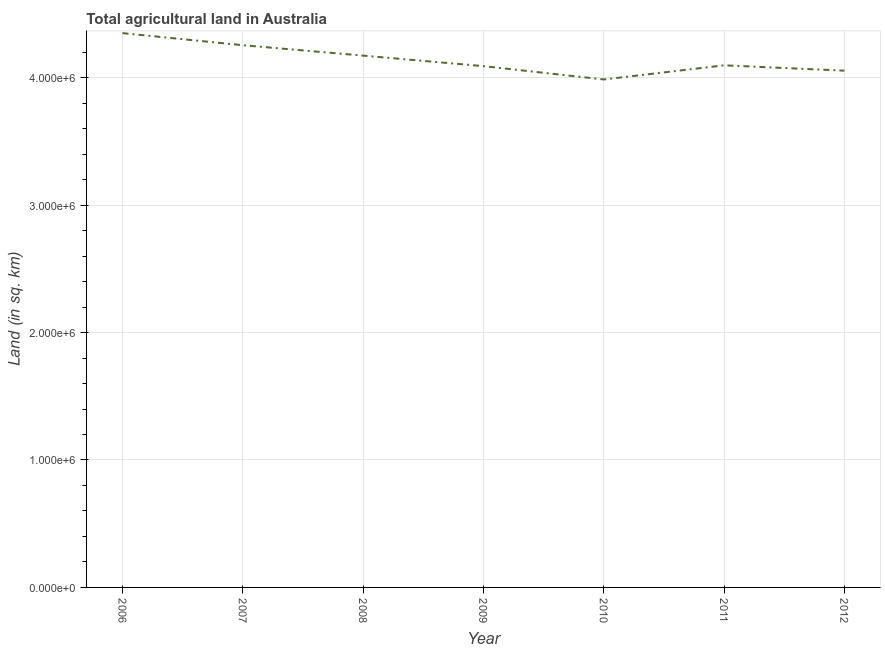What is the agricultural land in 2007?
Offer a terse response. 4.25e+06. Across all years, what is the maximum agricultural land?
Ensure brevity in your answer.  4.35e+06. Across all years, what is the minimum agricultural land?
Your answer should be very brief. 3.99e+06. What is the sum of the agricultural land?
Keep it short and to the point. 2.90e+07. What is the difference between the agricultural land in 2008 and 2009?
Offer a very short reply. 8.26e+04. What is the average agricultural land per year?
Offer a very short reply. 4.14e+06. What is the median agricultural land?
Your answer should be very brief. 4.10e+06. In how many years, is the agricultural land greater than 200000 sq. km?
Ensure brevity in your answer.  7. What is the ratio of the agricultural land in 2008 to that in 2011?
Provide a short and direct response. 1.02. Is the agricultural land in 2006 less than that in 2012?
Keep it short and to the point. No. What is the difference between the highest and the second highest agricultural land?
Your answer should be very brief. 9.48e+04. What is the difference between the highest and the lowest agricultural land?
Offer a very short reply. 3.63e+05. In how many years, is the agricultural land greater than the average agricultural land taken over all years?
Ensure brevity in your answer.  3. Does the agricultural land monotonically increase over the years?
Your answer should be very brief. No. How many lines are there?
Provide a short and direct response. 1. How many years are there in the graph?
Ensure brevity in your answer.  7. What is the difference between two consecutive major ticks on the Y-axis?
Provide a succinct answer. 1.00e+06. Are the values on the major ticks of Y-axis written in scientific E-notation?
Make the answer very short. Yes. Does the graph contain any zero values?
Your response must be concise. No. What is the title of the graph?
Provide a short and direct response. Total agricultural land in Australia. What is the label or title of the Y-axis?
Ensure brevity in your answer.  Land (in sq. km). What is the Land (in sq. km) in 2006?
Give a very brief answer. 4.35e+06. What is the Land (in sq. km) of 2007?
Offer a very short reply. 4.25e+06. What is the Land (in sq. km) in 2008?
Ensure brevity in your answer.  4.17e+06. What is the Land (in sq. km) in 2009?
Provide a short and direct response. 4.09e+06. What is the Land (in sq. km) in 2010?
Your response must be concise. 3.99e+06. What is the Land (in sq. km) in 2011?
Your answer should be compact. 4.10e+06. What is the Land (in sq. km) of 2012?
Offer a very short reply. 4.05e+06. What is the difference between the Land (in sq. km) in 2006 and 2007?
Offer a very short reply. 9.48e+04. What is the difference between the Land (in sq. km) in 2006 and 2008?
Give a very brief answer. 1.76e+05. What is the difference between the Land (in sq. km) in 2006 and 2009?
Provide a succinct answer. 2.59e+05. What is the difference between the Land (in sq. km) in 2006 and 2010?
Give a very brief answer. 3.63e+05. What is the difference between the Land (in sq. km) in 2006 and 2011?
Your answer should be compact. 2.53e+05. What is the difference between the Land (in sq. km) in 2006 and 2012?
Ensure brevity in your answer.  2.95e+05. What is the difference between the Land (in sq. km) in 2007 and 2008?
Keep it short and to the point. 8.16e+04. What is the difference between the Land (in sq. km) in 2007 and 2009?
Provide a succinct answer. 1.64e+05. What is the difference between the Land (in sq. km) in 2007 and 2010?
Make the answer very short. 2.69e+05. What is the difference between the Land (in sq. km) in 2007 and 2011?
Ensure brevity in your answer.  1.58e+05. What is the difference between the Land (in sq. km) in 2007 and 2012?
Your answer should be compact. 2.00e+05. What is the difference between the Land (in sq. km) in 2008 and 2009?
Offer a terse response. 8.26e+04. What is the difference between the Land (in sq. km) in 2008 and 2010?
Your response must be concise. 1.87e+05. What is the difference between the Land (in sq. km) in 2008 and 2011?
Your response must be concise. 7.62e+04. What is the difference between the Land (in sq. km) in 2008 and 2012?
Make the answer very short. 1.18e+05. What is the difference between the Land (in sq. km) in 2009 and 2010?
Provide a short and direct response. 1.04e+05. What is the difference between the Land (in sq. km) in 2009 and 2011?
Provide a short and direct response. -6436. What is the difference between the Land (in sq. km) in 2009 and 2012?
Your answer should be compact. 3.56e+04. What is the difference between the Land (in sq. km) in 2010 and 2011?
Offer a terse response. -1.11e+05. What is the difference between the Land (in sq. km) in 2010 and 2012?
Your response must be concise. -6.89e+04. What is the difference between the Land (in sq. km) in 2011 and 2012?
Ensure brevity in your answer.  4.20e+04. What is the ratio of the Land (in sq. km) in 2006 to that in 2008?
Give a very brief answer. 1.04. What is the ratio of the Land (in sq. km) in 2006 to that in 2009?
Offer a terse response. 1.06. What is the ratio of the Land (in sq. km) in 2006 to that in 2010?
Your answer should be very brief. 1.09. What is the ratio of the Land (in sq. km) in 2006 to that in 2011?
Your answer should be very brief. 1.06. What is the ratio of the Land (in sq. km) in 2006 to that in 2012?
Ensure brevity in your answer.  1.07. What is the ratio of the Land (in sq. km) in 2007 to that in 2008?
Give a very brief answer. 1.02. What is the ratio of the Land (in sq. km) in 2007 to that in 2009?
Give a very brief answer. 1.04. What is the ratio of the Land (in sq. km) in 2007 to that in 2010?
Keep it short and to the point. 1.07. What is the ratio of the Land (in sq. km) in 2007 to that in 2011?
Your answer should be compact. 1.04. What is the ratio of the Land (in sq. km) in 2007 to that in 2012?
Make the answer very short. 1.05. What is the ratio of the Land (in sq. km) in 2008 to that in 2009?
Give a very brief answer. 1.02. What is the ratio of the Land (in sq. km) in 2008 to that in 2010?
Make the answer very short. 1.05. What is the ratio of the Land (in sq. km) in 2009 to that in 2011?
Provide a short and direct response. 1. What is the ratio of the Land (in sq. km) in 2010 to that in 2012?
Ensure brevity in your answer.  0.98. What is the ratio of the Land (in sq. km) in 2011 to that in 2012?
Ensure brevity in your answer.  1.01. 